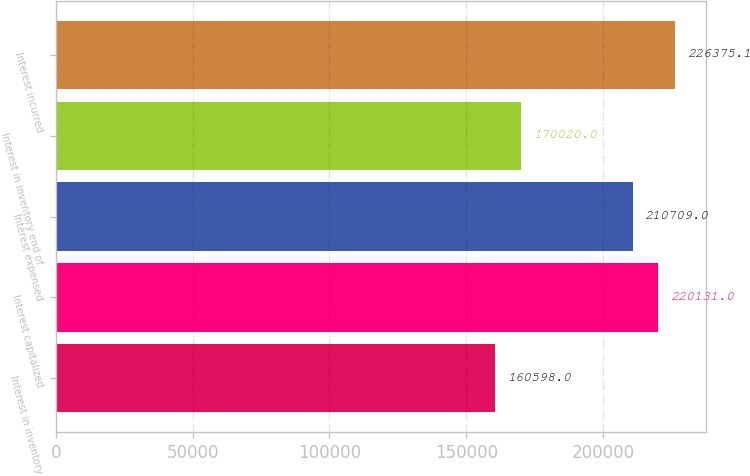Convert chart. <chart><loc_0><loc_0><loc_500><loc_500><bar_chart><fcel>Interest in inventory<fcel>Interest capitalized<fcel>Interest expensed<fcel>Interest in inventory end of<fcel>Interest incurred<nl><fcel>160598<fcel>220131<fcel>210709<fcel>170020<fcel>226375<nl></chart> 